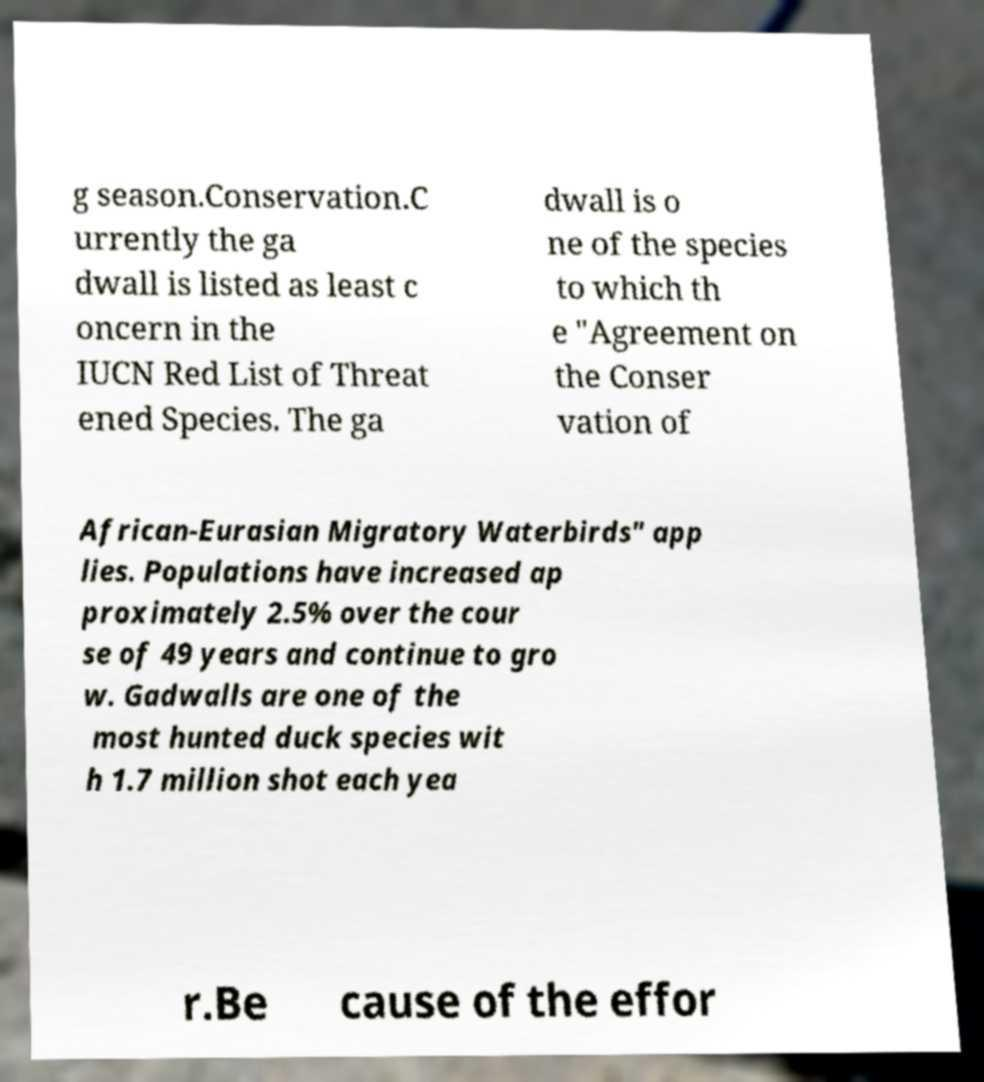Please read and relay the text visible in this image. What does it say? g season.Conservation.C urrently the ga dwall is listed as least c oncern in the IUCN Red List of Threat ened Species. The ga dwall is o ne of the species to which th e "Agreement on the Conser vation of African-Eurasian Migratory Waterbirds" app lies. Populations have increased ap proximately 2.5% over the cour se of 49 years and continue to gro w. Gadwalls are one of the most hunted duck species wit h 1.7 million shot each yea r.Be cause of the effor 